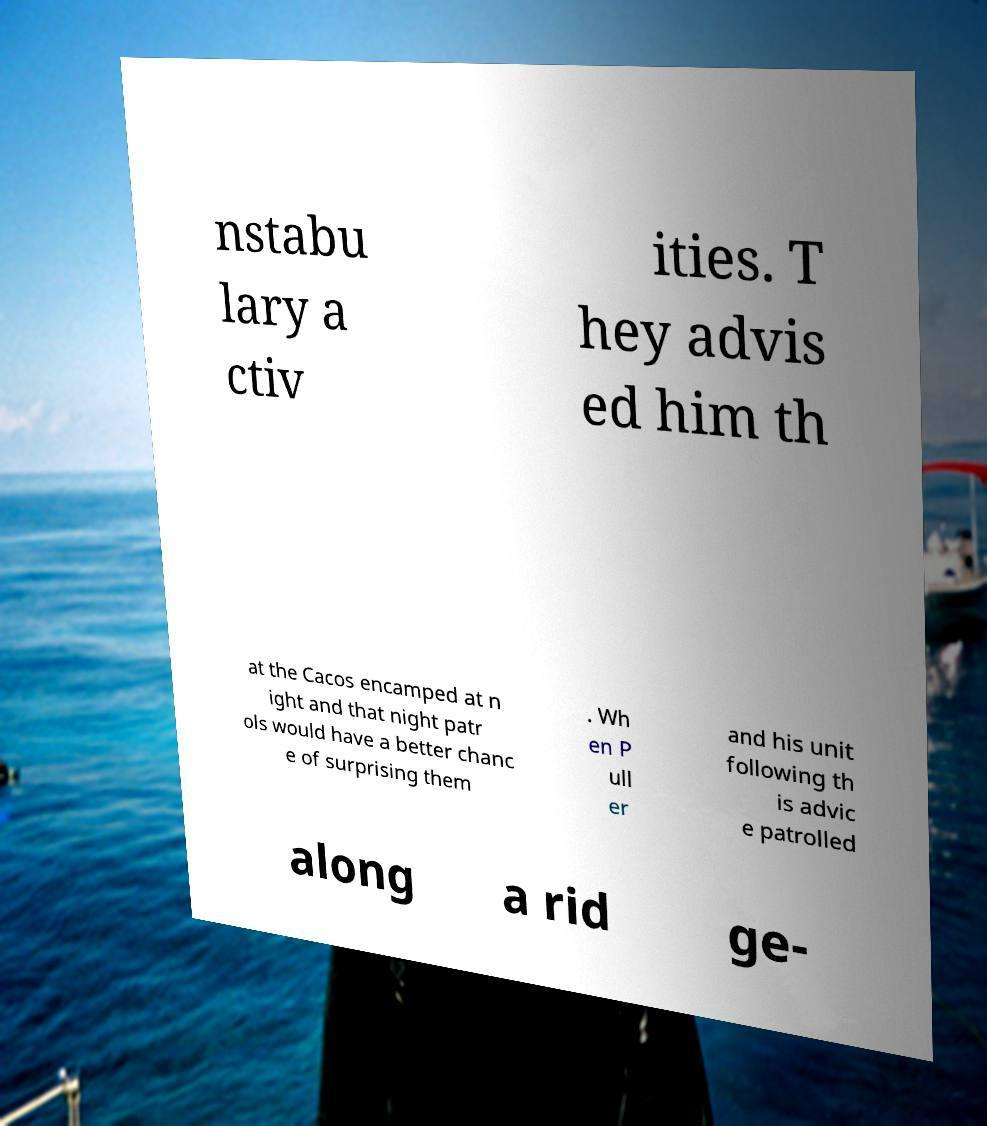I need the written content from this picture converted into text. Can you do that? nstabu lary a ctiv ities. T hey advis ed him th at the Cacos encamped at n ight and that night patr ols would have a better chanc e of surprising them . Wh en P ull er and his unit following th is advic e patrolled along a rid ge- 